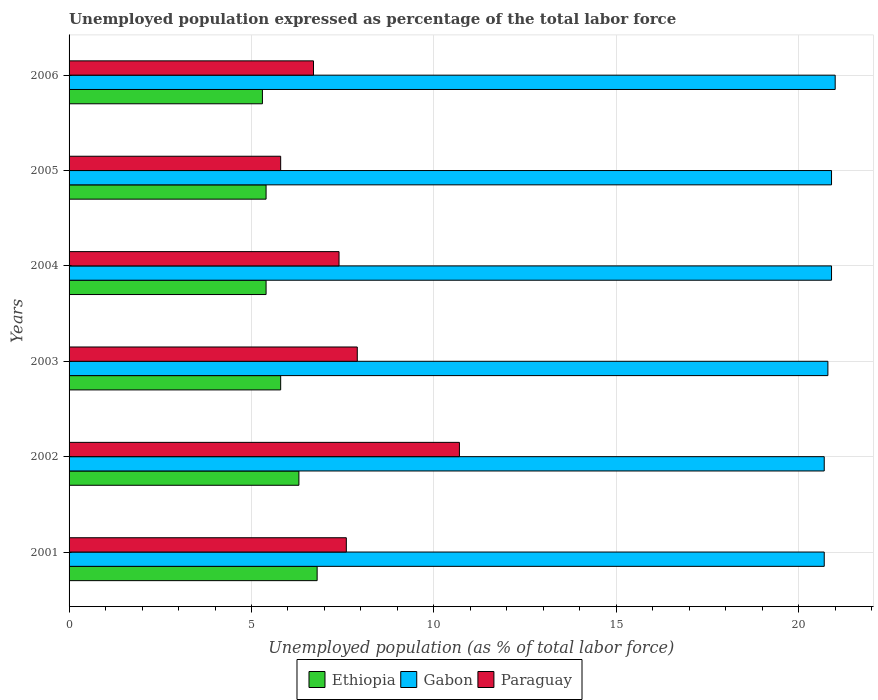How many bars are there on the 3rd tick from the bottom?
Offer a very short reply. 3. What is the unemployment in in Ethiopia in 2001?
Make the answer very short. 6.8. Across all years, what is the maximum unemployment in in Ethiopia?
Offer a terse response. 6.8. Across all years, what is the minimum unemployment in in Ethiopia?
Offer a very short reply. 5.3. In which year was the unemployment in in Gabon maximum?
Provide a succinct answer. 2006. What is the total unemployment in in Gabon in the graph?
Your answer should be very brief. 125. What is the difference between the unemployment in in Paraguay in 2002 and that in 2003?
Offer a very short reply. 2.8. What is the difference between the unemployment in in Gabon in 2006 and the unemployment in in Ethiopia in 2002?
Your answer should be compact. 14.7. What is the average unemployment in in Gabon per year?
Provide a succinct answer. 20.83. In the year 2002, what is the difference between the unemployment in in Ethiopia and unemployment in in Gabon?
Offer a very short reply. -14.4. In how many years, is the unemployment in in Gabon greater than 8 %?
Offer a terse response. 6. What is the ratio of the unemployment in in Gabon in 2001 to that in 2005?
Give a very brief answer. 0.99. What is the difference between the highest and the second highest unemployment in in Gabon?
Provide a short and direct response. 0.1. What is the difference between the highest and the lowest unemployment in in Ethiopia?
Keep it short and to the point. 1.5. In how many years, is the unemployment in in Gabon greater than the average unemployment in in Gabon taken over all years?
Provide a succinct answer. 3. Is the sum of the unemployment in in Ethiopia in 2004 and 2005 greater than the maximum unemployment in in Paraguay across all years?
Your answer should be compact. Yes. What does the 1st bar from the top in 2003 represents?
Give a very brief answer. Paraguay. What does the 2nd bar from the bottom in 2002 represents?
Your answer should be very brief. Gabon. Is it the case that in every year, the sum of the unemployment in in Gabon and unemployment in in Paraguay is greater than the unemployment in in Ethiopia?
Offer a very short reply. Yes. How many years are there in the graph?
Ensure brevity in your answer.  6. Are the values on the major ticks of X-axis written in scientific E-notation?
Provide a succinct answer. No. Does the graph contain grids?
Keep it short and to the point. Yes. How many legend labels are there?
Offer a terse response. 3. How are the legend labels stacked?
Offer a very short reply. Horizontal. What is the title of the graph?
Provide a short and direct response. Unemployed population expressed as percentage of the total labor force. What is the label or title of the X-axis?
Ensure brevity in your answer.  Unemployed population (as % of total labor force). What is the Unemployed population (as % of total labor force) of Ethiopia in 2001?
Offer a very short reply. 6.8. What is the Unemployed population (as % of total labor force) of Gabon in 2001?
Offer a terse response. 20.7. What is the Unemployed population (as % of total labor force) of Paraguay in 2001?
Your answer should be very brief. 7.6. What is the Unemployed population (as % of total labor force) of Ethiopia in 2002?
Keep it short and to the point. 6.3. What is the Unemployed population (as % of total labor force) in Gabon in 2002?
Your answer should be compact. 20.7. What is the Unemployed population (as % of total labor force) in Paraguay in 2002?
Your response must be concise. 10.7. What is the Unemployed population (as % of total labor force) of Ethiopia in 2003?
Make the answer very short. 5.8. What is the Unemployed population (as % of total labor force) in Gabon in 2003?
Ensure brevity in your answer.  20.8. What is the Unemployed population (as % of total labor force) of Paraguay in 2003?
Make the answer very short. 7.9. What is the Unemployed population (as % of total labor force) in Ethiopia in 2004?
Make the answer very short. 5.4. What is the Unemployed population (as % of total labor force) in Gabon in 2004?
Your answer should be compact. 20.9. What is the Unemployed population (as % of total labor force) in Paraguay in 2004?
Make the answer very short. 7.4. What is the Unemployed population (as % of total labor force) in Ethiopia in 2005?
Offer a very short reply. 5.4. What is the Unemployed population (as % of total labor force) in Gabon in 2005?
Offer a terse response. 20.9. What is the Unemployed population (as % of total labor force) in Paraguay in 2005?
Provide a succinct answer. 5.8. What is the Unemployed population (as % of total labor force) in Ethiopia in 2006?
Ensure brevity in your answer.  5.3. What is the Unemployed population (as % of total labor force) of Gabon in 2006?
Your answer should be very brief. 21. What is the Unemployed population (as % of total labor force) of Paraguay in 2006?
Provide a succinct answer. 6.7. Across all years, what is the maximum Unemployed population (as % of total labor force) of Ethiopia?
Give a very brief answer. 6.8. Across all years, what is the maximum Unemployed population (as % of total labor force) of Gabon?
Offer a terse response. 21. Across all years, what is the maximum Unemployed population (as % of total labor force) of Paraguay?
Your answer should be compact. 10.7. Across all years, what is the minimum Unemployed population (as % of total labor force) of Ethiopia?
Ensure brevity in your answer.  5.3. Across all years, what is the minimum Unemployed population (as % of total labor force) of Gabon?
Make the answer very short. 20.7. Across all years, what is the minimum Unemployed population (as % of total labor force) of Paraguay?
Your response must be concise. 5.8. What is the total Unemployed population (as % of total labor force) of Gabon in the graph?
Provide a succinct answer. 125. What is the total Unemployed population (as % of total labor force) of Paraguay in the graph?
Keep it short and to the point. 46.1. What is the difference between the Unemployed population (as % of total labor force) of Ethiopia in 2001 and that in 2002?
Your response must be concise. 0.5. What is the difference between the Unemployed population (as % of total labor force) of Gabon in 2001 and that in 2002?
Give a very brief answer. 0. What is the difference between the Unemployed population (as % of total labor force) of Paraguay in 2001 and that in 2003?
Your response must be concise. -0.3. What is the difference between the Unemployed population (as % of total labor force) in Ethiopia in 2001 and that in 2005?
Make the answer very short. 1.4. What is the difference between the Unemployed population (as % of total labor force) in Gabon in 2002 and that in 2003?
Ensure brevity in your answer.  -0.1. What is the difference between the Unemployed population (as % of total labor force) of Paraguay in 2002 and that in 2003?
Your answer should be very brief. 2.8. What is the difference between the Unemployed population (as % of total labor force) of Ethiopia in 2002 and that in 2004?
Give a very brief answer. 0.9. What is the difference between the Unemployed population (as % of total labor force) of Gabon in 2002 and that in 2004?
Your answer should be very brief. -0.2. What is the difference between the Unemployed population (as % of total labor force) of Paraguay in 2002 and that in 2004?
Your response must be concise. 3.3. What is the difference between the Unemployed population (as % of total labor force) in Ethiopia in 2002 and that in 2005?
Your answer should be very brief. 0.9. What is the difference between the Unemployed population (as % of total labor force) of Gabon in 2002 and that in 2005?
Provide a short and direct response. -0.2. What is the difference between the Unemployed population (as % of total labor force) of Gabon in 2002 and that in 2006?
Your answer should be very brief. -0.3. What is the difference between the Unemployed population (as % of total labor force) of Gabon in 2003 and that in 2004?
Give a very brief answer. -0.1. What is the difference between the Unemployed population (as % of total labor force) of Ethiopia in 2003 and that in 2005?
Make the answer very short. 0.4. What is the difference between the Unemployed population (as % of total labor force) in Gabon in 2003 and that in 2005?
Your answer should be very brief. -0.1. What is the difference between the Unemployed population (as % of total labor force) of Paraguay in 2003 and that in 2005?
Give a very brief answer. 2.1. What is the difference between the Unemployed population (as % of total labor force) of Ethiopia in 2003 and that in 2006?
Give a very brief answer. 0.5. What is the difference between the Unemployed population (as % of total labor force) of Gabon in 2003 and that in 2006?
Your answer should be compact. -0.2. What is the difference between the Unemployed population (as % of total labor force) of Ethiopia in 2004 and that in 2005?
Offer a very short reply. 0. What is the difference between the Unemployed population (as % of total labor force) in Ethiopia in 2004 and that in 2006?
Offer a terse response. 0.1. What is the difference between the Unemployed population (as % of total labor force) in Gabon in 2004 and that in 2006?
Provide a short and direct response. -0.1. What is the difference between the Unemployed population (as % of total labor force) in Paraguay in 2004 and that in 2006?
Offer a very short reply. 0.7. What is the difference between the Unemployed population (as % of total labor force) of Ethiopia in 2005 and that in 2006?
Provide a short and direct response. 0.1. What is the difference between the Unemployed population (as % of total labor force) in Ethiopia in 2001 and the Unemployed population (as % of total labor force) in Gabon in 2002?
Offer a very short reply. -13.9. What is the difference between the Unemployed population (as % of total labor force) of Gabon in 2001 and the Unemployed population (as % of total labor force) of Paraguay in 2002?
Make the answer very short. 10. What is the difference between the Unemployed population (as % of total labor force) in Ethiopia in 2001 and the Unemployed population (as % of total labor force) in Paraguay in 2003?
Keep it short and to the point. -1.1. What is the difference between the Unemployed population (as % of total labor force) in Ethiopia in 2001 and the Unemployed population (as % of total labor force) in Gabon in 2004?
Ensure brevity in your answer.  -14.1. What is the difference between the Unemployed population (as % of total labor force) in Ethiopia in 2001 and the Unemployed population (as % of total labor force) in Paraguay in 2004?
Give a very brief answer. -0.6. What is the difference between the Unemployed population (as % of total labor force) of Gabon in 2001 and the Unemployed population (as % of total labor force) of Paraguay in 2004?
Keep it short and to the point. 13.3. What is the difference between the Unemployed population (as % of total labor force) of Ethiopia in 2001 and the Unemployed population (as % of total labor force) of Gabon in 2005?
Provide a short and direct response. -14.1. What is the difference between the Unemployed population (as % of total labor force) in Ethiopia in 2001 and the Unemployed population (as % of total labor force) in Gabon in 2006?
Give a very brief answer. -14.2. What is the difference between the Unemployed population (as % of total labor force) in Ethiopia in 2001 and the Unemployed population (as % of total labor force) in Paraguay in 2006?
Offer a terse response. 0.1. What is the difference between the Unemployed population (as % of total labor force) in Gabon in 2001 and the Unemployed population (as % of total labor force) in Paraguay in 2006?
Ensure brevity in your answer.  14. What is the difference between the Unemployed population (as % of total labor force) of Ethiopia in 2002 and the Unemployed population (as % of total labor force) of Paraguay in 2003?
Make the answer very short. -1.6. What is the difference between the Unemployed population (as % of total labor force) in Gabon in 2002 and the Unemployed population (as % of total labor force) in Paraguay in 2003?
Your response must be concise. 12.8. What is the difference between the Unemployed population (as % of total labor force) in Ethiopia in 2002 and the Unemployed population (as % of total labor force) in Gabon in 2004?
Make the answer very short. -14.6. What is the difference between the Unemployed population (as % of total labor force) of Ethiopia in 2002 and the Unemployed population (as % of total labor force) of Gabon in 2005?
Ensure brevity in your answer.  -14.6. What is the difference between the Unemployed population (as % of total labor force) in Ethiopia in 2002 and the Unemployed population (as % of total labor force) in Paraguay in 2005?
Your answer should be compact. 0.5. What is the difference between the Unemployed population (as % of total labor force) in Gabon in 2002 and the Unemployed population (as % of total labor force) in Paraguay in 2005?
Give a very brief answer. 14.9. What is the difference between the Unemployed population (as % of total labor force) in Ethiopia in 2002 and the Unemployed population (as % of total labor force) in Gabon in 2006?
Your answer should be very brief. -14.7. What is the difference between the Unemployed population (as % of total labor force) of Ethiopia in 2002 and the Unemployed population (as % of total labor force) of Paraguay in 2006?
Make the answer very short. -0.4. What is the difference between the Unemployed population (as % of total labor force) of Ethiopia in 2003 and the Unemployed population (as % of total labor force) of Gabon in 2004?
Keep it short and to the point. -15.1. What is the difference between the Unemployed population (as % of total labor force) of Ethiopia in 2003 and the Unemployed population (as % of total labor force) of Paraguay in 2004?
Your answer should be very brief. -1.6. What is the difference between the Unemployed population (as % of total labor force) of Gabon in 2003 and the Unemployed population (as % of total labor force) of Paraguay in 2004?
Offer a very short reply. 13.4. What is the difference between the Unemployed population (as % of total labor force) of Ethiopia in 2003 and the Unemployed population (as % of total labor force) of Gabon in 2005?
Make the answer very short. -15.1. What is the difference between the Unemployed population (as % of total labor force) of Gabon in 2003 and the Unemployed population (as % of total labor force) of Paraguay in 2005?
Ensure brevity in your answer.  15. What is the difference between the Unemployed population (as % of total labor force) of Ethiopia in 2003 and the Unemployed population (as % of total labor force) of Gabon in 2006?
Provide a succinct answer. -15.2. What is the difference between the Unemployed population (as % of total labor force) of Ethiopia in 2004 and the Unemployed population (as % of total labor force) of Gabon in 2005?
Ensure brevity in your answer.  -15.5. What is the difference between the Unemployed population (as % of total labor force) of Ethiopia in 2004 and the Unemployed population (as % of total labor force) of Paraguay in 2005?
Ensure brevity in your answer.  -0.4. What is the difference between the Unemployed population (as % of total labor force) of Ethiopia in 2004 and the Unemployed population (as % of total labor force) of Gabon in 2006?
Provide a short and direct response. -15.6. What is the difference between the Unemployed population (as % of total labor force) of Ethiopia in 2004 and the Unemployed population (as % of total labor force) of Paraguay in 2006?
Your response must be concise. -1.3. What is the difference between the Unemployed population (as % of total labor force) in Gabon in 2004 and the Unemployed population (as % of total labor force) in Paraguay in 2006?
Ensure brevity in your answer.  14.2. What is the difference between the Unemployed population (as % of total labor force) in Ethiopia in 2005 and the Unemployed population (as % of total labor force) in Gabon in 2006?
Offer a terse response. -15.6. What is the average Unemployed population (as % of total labor force) of Ethiopia per year?
Offer a terse response. 5.83. What is the average Unemployed population (as % of total labor force) in Gabon per year?
Ensure brevity in your answer.  20.83. What is the average Unemployed population (as % of total labor force) of Paraguay per year?
Your response must be concise. 7.68. In the year 2001, what is the difference between the Unemployed population (as % of total labor force) of Ethiopia and Unemployed population (as % of total labor force) of Paraguay?
Ensure brevity in your answer.  -0.8. In the year 2001, what is the difference between the Unemployed population (as % of total labor force) of Gabon and Unemployed population (as % of total labor force) of Paraguay?
Keep it short and to the point. 13.1. In the year 2002, what is the difference between the Unemployed population (as % of total labor force) of Ethiopia and Unemployed population (as % of total labor force) of Gabon?
Your answer should be very brief. -14.4. In the year 2003, what is the difference between the Unemployed population (as % of total labor force) of Ethiopia and Unemployed population (as % of total labor force) of Paraguay?
Your answer should be very brief. -2.1. In the year 2004, what is the difference between the Unemployed population (as % of total labor force) of Ethiopia and Unemployed population (as % of total labor force) of Gabon?
Give a very brief answer. -15.5. In the year 2004, what is the difference between the Unemployed population (as % of total labor force) of Gabon and Unemployed population (as % of total labor force) of Paraguay?
Provide a short and direct response. 13.5. In the year 2005, what is the difference between the Unemployed population (as % of total labor force) in Ethiopia and Unemployed population (as % of total labor force) in Gabon?
Provide a succinct answer. -15.5. In the year 2005, what is the difference between the Unemployed population (as % of total labor force) of Gabon and Unemployed population (as % of total labor force) of Paraguay?
Provide a succinct answer. 15.1. In the year 2006, what is the difference between the Unemployed population (as % of total labor force) of Ethiopia and Unemployed population (as % of total labor force) of Gabon?
Provide a short and direct response. -15.7. In the year 2006, what is the difference between the Unemployed population (as % of total labor force) of Ethiopia and Unemployed population (as % of total labor force) of Paraguay?
Offer a very short reply. -1.4. What is the ratio of the Unemployed population (as % of total labor force) of Ethiopia in 2001 to that in 2002?
Provide a short and direct response. 1.08. What is the ratio of the Unemployed population (as % of total labor force) of Gabon in 2001 to that in 2002?
Give a very brief answer. 1. What is the ratio of the Unemployed population (as % of total labor force) in Paraguay in 2001 to that in 2002?
Your response must be concise. 0.71. What is the ratio of the Unemployed population (as % of total labor force) in Ethiopia in 2001 to that in 2003?
Ensure brevity in your answer.  1.17. What is the ratio of the Unemployed population (as % of total labor force) in Gabon in 2001 to that in 2003?
Your answer should be very brief. 1. What is the ratio of the Unemployed population (as % of total labor force) in Ethiopia in 2001 to that in 2004?
Make the answer very short. 1.26. What is the ratio of the Unemployed population (as % of total labor force) of Paraguay in 2001 to that in 2004?
Provide a succinct answer. 1.03. What is the ratio of the Unemployed population (as % of total labor force) in Ethiopia in 2001 to that in 2005?
Your answer should be compact. 1.26. What is the ratio of the Unemployed population (as % of total labor force) of Paraguay in 2001 to that in 2005?
Your response must be concise. 1.31. What is the ratio of the Unemployed population (as % of total labor force) in Ethiopia in 2001 to that in 2006?
Your answer should be very brief. 1.28. What is the ratio of the Unemployed population (as % of total labor force) of Gabon in 2001 to that in 2006?
Offer a very short reply. 0.99. What is the ratio of the Unemployed population (as % of total labor force) of Paraguay in 2001 to that in 2006?
Offer a very short reply. 1.13. What is the ratio of the Unemployed population (as % of total labor force) of Ethiopia in 2002 to that in 2003?
Provide a short and direct response. 1.09. What is the ratio of the Unemployed population (as % of total labor force) in Paraguay in 2002 to that in 2003?
Your answer should be very brief. 1.35. What is the ratio of the Unemployed population (as % of total labor force) in Paraguay in 2002 to that in 2004?
Make the answer very short. 1.45. What is the ratio of the Unemployed population (as % of total labor force) of Gabon in 2002 to that in 2005?
Your answer should be compact. 0.99. What is the ratio of the Unemployed population (as % of total labor force) of Paraguay in 2002 to that in 2005?
Provide a short and direct response. 1.84. What is the ratio of the Unemployed population (as % of total labor force) in Ethiopia in 2002 to that in 2006?
Keep it short and to the point. 1.19. What is the ratio of the Unemployed population (as % of total labor force) of Gabon in 2002 to that in 2006?
Your answer should be compact. 0.99. What is the ratio of the Unemployed population (as % of total labor force) of Paraguay in 2002 to that in 2006?
Offer a very short reply. 1.6. What is the ratio of the Unemployed population (as % of total labor force) in Ethiopia in 2003 to that in 2004?
Give a very brief answer. 1.07. What is the ratio of the Unemployed population (as % of total labor force) in Paraguay in 2003 to that in 2004?
Keep it short and to the point. 1.07. What is the ratio of the Unemployed population (as % of total labor force) of Ethiopia in 2003 to that in 2005?
Offer a very short reply. 1.07. What is the ratio of the Unemployed population (as % of total labor force) in Gabon in 2003 to that in 2005?
Offer a very short reply. 1. What is the ratio of the Unemployed population (as % of total labor force) in Paraguay in 2003 to that in 2005?
Your response must be concise. 1.36. What is the ratio of the Unemployed population (as % of total labor force) in Ethiopia in 2003 to that in 2006?
Provide a succinct answer. 1.09. What is the ratio of the Unemployed population (as % of total labor force) of Gabon in 2003 to that in 2006?
Make the answer very short. 0.99. What is the ratio of the Unemployed population (as % of total labor force) in Paraguay in 2003 to that in 2006?
Your answer should be compact. 1.18. What is the ratio of the Unemployed population (as % of total labor force) of Ethiopia in 2004 to that in 2005?
Your response must be concise. 1. What is the ratio of the Unemployed population (as % of total labor force) of Gabon in 2004 to that in 2005?
Keep it short and to the point. 1. What is the ratio of the Unemployed population (as % of total labor force) of Paraguay in 2004 to that in 2005?
Give a very brief answer. 1.28. What is the ratio of the Unemployed population (as % of total labor force) in Ethiopia in 2004 to that in 2006?
Provide a short and direct response. 1.02. What is the ratio of the Unemployed population (as % of total labor force) in Gabon in 2004 to that in 2006?
Give a very brief answer. 1. What is the ratio of the Unemployed population (as % of total labor force) of Paraguay in 2004 to that in 2006?
Your answer should be very brief. 1.1. What is the ratio of the Unemployed population (as % of total labor force) in Ethiopia in 2005 to that in 2006?
Your answer should be very brief. 1.02. What is the ratio of the Unemployed population (as % of total labor force) in Gabon in 2005 to that in 2006?
Keep it short and to the point. 1. What is the ratio of the Unemployed population (as % of total labor force) in Paraguay in 2005 to that in 2006?
Offer a terse response. 0.87. 